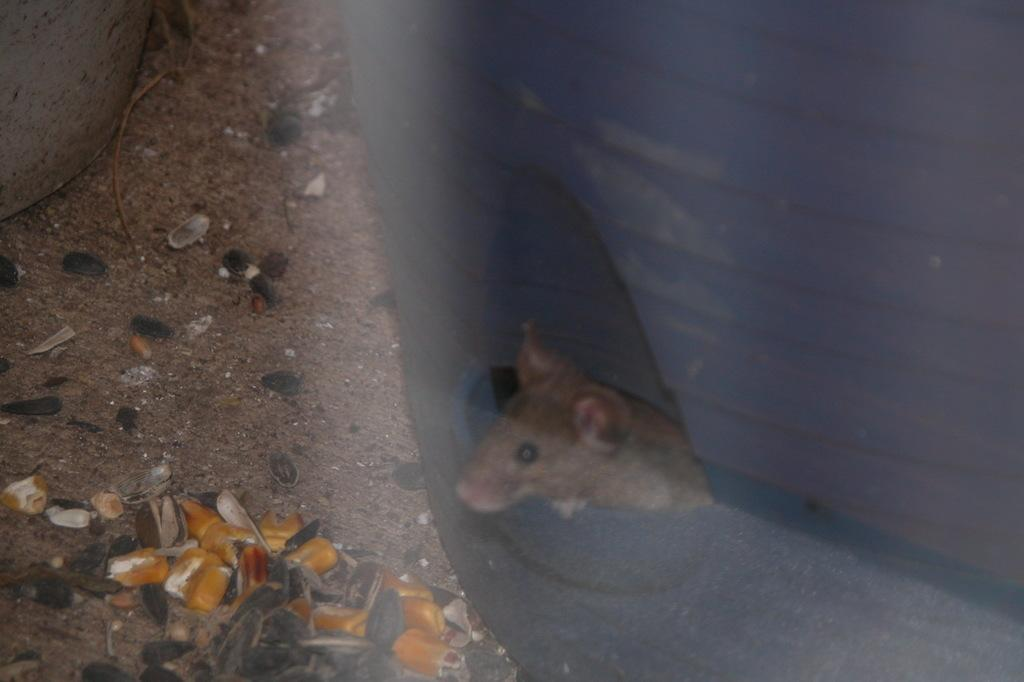What is depicted in the painting on the object in the image? There is a painting of a rat on an object and a painting of the sky and clouds on another object. What can be found at the bottom of the image? There are shells at the bottom of the image. What is the main subject in the image? There is an object in the image. What type of dirt can be seen on the expert's shoes in the image? There is no expert or dirt present in the image. 